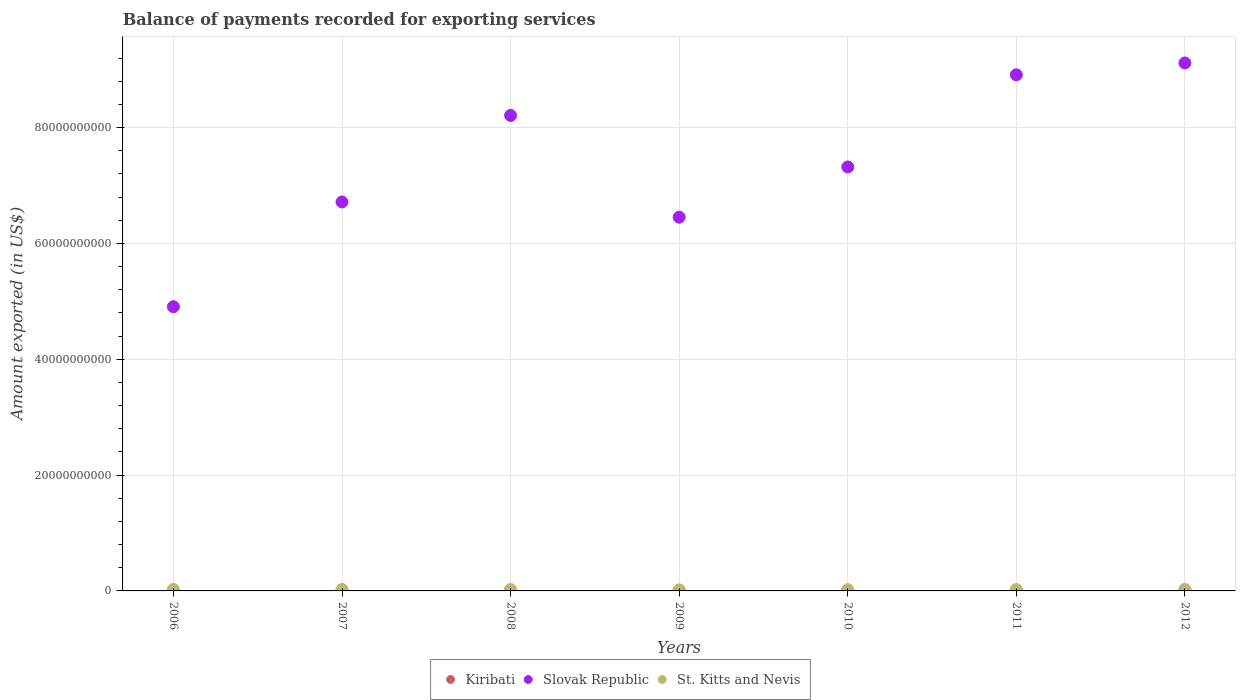What is the amount exported in St. Kitts and Nevis in 2008?
Offer a very short reply. 2.45e+08. Across all years, what is the maximum amount exported in St. Kitts and Nevis?
Ensure brevity in your answer.  2.63e+08. Across all years, what is the minimum amount exported in Slovak Republic?
Offer a terse response. 4.91e+1. In which year was the amount exported in Slovak Republic minimum?
Your answer should be very brief. 2006. What is the total amount exported in St. Kitts and Nevis in the graph?
Offer a terse response. 1.65e+09. What is the difference between the amount exported in Slovak Republic in 2009 and that in 2010?
Your response must be concise. -8.68e+09. What is the difference between the amount exported in St. Kitts and Nevis in 2011 and the amount exported in Kiribati in 2007?
Provide a succinct answer. 1.66e+08. What is the average amount exported in St. Kitts and Nevis per year?
Ensure brevity in your answer.  2.36e+08. In the year 2012, what is the difference between the amount exported in Slovak Republic and amount exported in St. Kitts and Nevis?
Offer a very short reply. 9.09e+1. What is the ratio of the amount exported in St. Kitts and Nevis in 2006 to that in 2012?
Provide a short and direct response. 0.95. Is the difference between the amount exported in Slovak Republic in 2008 and 2012 greater than the difference between the amount exported in St. Kitts and Nevis in 2008 and 2012?
Provide a succinct answer. No. What is the difference between the highest and the second highest amount exported in Kiribati?
Keep it short and to the point. 2.69e+07. What is the difference between the highest and the lowest amount exported in Kiribati?
Offer a terse response. 6.40e+07. In how many years, is the amount exported in St. Kitts and Nevis greater than the average amount exported in St. Kitts and Nevis taken over all years?
Give a very brief answer. 5. Is it the case that in every year, the sum of the amount exported in St. Kitts and Nevis and amount exported in Slovak Republic  is greater than the amount exported in Kiribati?
Make the answer very short. Yes. Does the amount exported in St. Kitts and Nevis monotonically increase over the years?
Keep it short and to the point. No. Is the amount exported in Kiribati strictly greater than the amount exported in St. Kitts and Nevis over the years?
Your answer should be very brief. No. How many dotlines are there?
Your answer should be very brief. 3. Are the values on the major ticks of Y-axis written in scientific E-notation?
Your answer should be very brief. No. Does the graph contain any zero values?
Your answer should be very brief. No. Does the graph contain grids?
Provide a short and direct response. Yes. Where does the legend appear in the graph?
Keep it short and to the point. Bottom center. What is the title of the graph?
Ensure brevity in your answer.  Balance of payments recorded for exporting services. What is the label or title of the Y-axis?
Your answer should be very brief. Amount exported (in US$). What is the Amount exported (in US$) in Kiribati in 2006?
Keep it short and to the point. 6.04e+07. What is the Amount exported (in US$) in Slovak Republic in 2006?
Ensure brevity in your answer.  4.91e+1. What is the Amount exported (in US$) of St. Kitts and Nevis in 2006?
Offer a terse response. 2.49e+08. What is the Amount exported (in US$) in Kiribati in 2007?
Your answer should be very brief. 8.29e+07. What is the Amount exported (in US$) of Slovak Republic in 2007?
Provide a short and direct response. 6.72e+1. What is the Amount exported (in US$) in St. Kitts and Nevis in 2007?
Keep it short and to the point. 2.48e+08. What is the Amount exported (in US$) in Kiribati in 2008?
Your answer should be very brief. 9.38e+07. What is the Amount exported (in US$) of Slovak Republic in 2008?
Offer a very short reply. 8.21e+1. What is the Amount exported (in US$) of St. Kitts and Nevis in 2008?
Offer a terse response. 2.45e+08. What is the Amount exported (in US$) of Kiribati in 2009?
Offer a terse response. 7.75e+07. What is the Amount exported (in US$) of Slovak Republic in 2009?
Your answer should be compact. 6.45e+1. What is the Amount exported (in US$) of St. Kitts and Nevis in 2009?
Offer a terse response. 1.85e+08. What is the Amount exported (in US$) of Kiribati in 2010?
Provide a short and direct response. 9.54e+07. What is the Amount exported (in US$) of Slovak Republic in 2010?
Keep it short and to the point. 7.32e+1. What is the Amount exported (in US$) in St. Kitts and Nevis in 2010?
Offer a terse response. 2.16e+08. What is the Amount exported (in US$) of Kiribati in 2011?
Keep it short and to the point. 9.75e+07. What is the Amount exported (in US$) of Slovak Republic in 2011?
Provide a short and direct response. 8.91e+1. What is the Amount exported (in US$) in St. Kitts and Nevis in 2011?
Your answer should be compact. 2.49e+08. What is the Amount exported (in US$) in Kiribati in 2012?
Provide a succinct answer. 1.24e+08. What is the Amount exported (in US$) in Slovak Republic in 2012?
Offer a terse response. 9.12e+1. What is the Amount exported (in US$) in St. Kitts and Nevis in 2012?
Your response must be concise. 2.63e+08. Across all years, what is the maximum Amount exported (in US$) in Kiribati?
Provide a succinct answer. 1.24e+08. Across all years, what is the maximum Amount exported (in US$) of Slovak Republic?
Ensure brevity in your answer.  9.12e+1. Across all years, what is the maximum Amount exported (in US$) in St. Kitts and Nevis?
Offer a very short reply. 2.63e+08. Across all years, what is the minimum Amount exported (in US$) of Kiribati?
Provide a succinct answer. 6.04e+07. Across all years, what is the minimum Amount exported (in US$) in Slovak Republic?
Make the answer very short. 4.91e+1. Across all years, what is the minimum Amount exported (in US$) of St. Kitts and Nevis?
Make the answer very short. 1.85e+08. What is the total Amount exported (in US$) of Kiribati in the graph?
Make the answer very short. 6.32e+08. What is the total Amount exported (in US$) of Slovak Republic in the graph?
Ensure brevity in your answer.  5.16e+11. What is the total Amount exported (in US$) of St. Kitts and Nevis in the graph?
Ensure brevity in your answer.  1.65e+09. What is the difference between the Amount exported (in US$) of Kiribati in 2006 and that in 2007?
Give a very brief answer. -2.25e+07. What is the difference between the Amount exported (in US$) in Slovak Republic in 2006 and that in 2007?
Make the answer very short. -1.81e+1. What is the difference between the Amount exported (in US$) of St. Kitts and Nevis in 2006 and that in 2007?
Your response must be concise. 1.23e+06. What is the difference between the Amount exported (in US$) of Kiribati in 2006 and that in 2008?
Keep it short and to the point. -3.34e+07. What is the difference between the Amount exported (in US$) in Slovak Republic in 2006 and that in 2008?
Provide a succinct answer. -3.30e+1. What is the difference between the Amount exported (in US$) of St. Kitts and Nevis in 2006 and that in 2008?
Your answer should be very brief. 4.29e+06. What is the difference between the Amount exported (in US$) of Kiribati in 2006 and that in 2009?
Make the answer very short. -1.72e+07. What is the difference between the Amount exported (in US$) of Slovak Republic in 2006 and that in 2009?
Offer a very short reply. -1.55e+1. What is the difference between the Amount exported (in US$) in St. Kitts and Nevis in 2006 and that in 2009?
Your response must be concise. 6.37e+07. What is the difference between the Amount exported (in US$) of Kiribati in 2006 and that in 2010?
Your answer should be compact. -3.50e+07. What is the difference between the Amount exported (in US$) in Slovak Republic in 2006 and that in 2010?
Your answer should be compact. -2.41e+1. What is the difference between the Amount exported (in US$) of St. Kitts and Nevis in 2006 and that in 2010?
Ensure brevity in your answer.  3.32e+07. What is the difference between the Amount exported (in US$) of Kiribati in 2006 and that in 2011?
Your answer should be compact. -3.71e+07. What is the difference between the Amount exported (in US$) of Slovak Republic in 2006 and that in 2011?
Your response must be concise. -4.01e+1. What is the difference between the Amount exported (in US$) of St. Kitts and Nevis in 2006 and that in 2011?
Make the answer very short. 5.48e+04. What is the difference between the Amount exported (in US$) of Kiribati in 2006 and that in 2012?
Give a very brief answer. -6.40e+07. What is the difference between the Amount exported (in US$) of Slovak Republic in 2006 and that in 2012?
Your response must be concise. -4.21e+1. What is the difference between the Amount exported (in US$) of St. Kitts and Nevis in 2006 and that in 2012?
Provide a short and direct response. -1.36e+07. What is the difference between the Amount exported (in US$) of Kiribati in 2007 and that in 2008?
Ensure brevity in your answer.  -1.09e+07. What is the difference between the Amount exported (in US$) of Slovak Republic in 2007 and that in 2008?
Offer a very short reply. -1.49e+1. What is the difference between the Amount exported (in US$) of St. Kitts and Nevis in 2007 and that in 2008?
Provide a succinct answer. 3.05e+06. What is the difference between the Amount exported (in US$) in Kiribati in 2007 and that in 2009?
Offer a terse response. 5.38e+06. What is the difference between the Amount exported (in US$) in Slovak Republic in 2007 and that in 2009?
Keep it short and to the point. 2.63e+09. What is the difference between the Amount exported (in US$) of St. Kitts and Nevis in 2007 and that in 2009?
Keep it short and to the point. 6.25e+07. What is the difference between the Amount exported (in US$) of Kiribati in 2007 and that in 2010?
Provide a succinct answer. -1.25e+07. What is the difference between the Amount exported (in US$) in Slovak Republic in 2007 and that in 2010?
Your answer should be compact. -6.05e+09. What is the difference between the Amount exported (in US$) of St. Kitts and Nevis in 2007 and that in 2010?
Make the answer very short. 3.19e+07. What is the difference between the Amount exported (in US$) in Kiribati in 2007 and that in 2011?
Keep it short and to the point. -1.46e+07. What is the difference between the Amount exported (in US$) of Slovak Republic in 2007 and that in 2011?
Your answer should be very brief. -2.20e+1. What is the difference between the Amount exported (in US$) of St. Kitts and Nevis in 2007 and that in 2011?
Offer a very short reply. -1.18e+06. What is the difference between the Amount exported (in US$) of Kiribati in 2007 and that in 2012?
Your answer should be compact. -4.15e+07. What is the difference between the Amount exported (in US$) of Slovak Republic in 2007 and that in 2012?
Offer a terse response. -2.40e+1. What is the difference between the Amount exported (in US$) of St. Kitts and Nevis in 2007 and that in 2012?
Make the answer very short. -1.48e+07. What is the difference between the Amount exported (in US$) in Kiribati in 2008 and that in 2009?
Offer a terse response. 1.63e+07. What is the difference between the Amount exported (in US$) of Slovak Republic in 2008 and that in 2009?
Make the answer very short. 1.76e+1. What is the difference between the Amount exported (in US$) of St. Kitts and Nevis in 2008 and that in 2009?
Ensure brevity in your answer.  5.94e+07. What is the difference between the Amount exported (in US$) in Kiribati in 2008 and that in 2010?
Your response must be concise. -1.56e+06. What is the difference between the Amount exported (in US$) of Slovak Republic in 2008 and that in 2010?
Offer a terse response. 8.89e+09. What is the difference between the Amount exported (in US$) in St. Kitts and Nevis in 2008 and that in 2010?
Offer a terse response. 2.89e+07. What is the difference between the Amount exported (in US$) of Kiribati in 2008 and that in 2011?
Your answer should be very brief. -3.68e+06. What is the difference between the Amount exported (in US$) in Slovak Republic in 2008 and that in 2011?
Make the answer very short. -7.02e+09. What is the difference between the Amount exported (in US$) in St. Kitts and Nevis in 2008 and that in 2011?
Offer a terse response. -4.23e+06. What is the difference between the Amount exported (in US$) in Kiribati in 2008 and that in 2012?
Your answer should be compact. -3.05e+07. What is the difference between the Amount exported (in US$) in Slovak Republic in 2008 and that in 2012?
Give a very brief answer. -9.07e+09. What is the difference between the Amount exported (in US$) in St. Kitts and Nevis in 2008 and that in 2012?
Offer a terse response. -1.79e+07. What is the difference between the Amount exported (in US$) in Kiribati in 2009 and that in 2010?
Offer a very short reply. -1.79e+07. What is the difference between the Amount exported (in US$) of Slovak Republic in 2009 and that in 2010?
Your response must be concise. -8.68e+09. What is the difference between the Amount exported (in US$) of St. Kitts and Nevis in 2009 and that in 2010?
Keep it short and to the point. -3.06e+07. What is the difference between the Amount exported (in US$) of Kiribati in 2009 and that in 2011?
Provide a short and direct response. -2.00e+07. What is the difference between the Amount exported (in US$) of Slovak Republic in 2009 and that in 2011?
Ensure brevity in your answer.  -2.46e+1. What is the difference between the Amount exported (in US$) of St. Kitts and Nevis in 2009 and that in 2011?
Your response must be concise. -6.37e+07. What is the difference between the Amount exported (in US$) in Kiribati in 2009 and that in 2012?
Keep it short and to the point. -4.68e+07. What is the difference between the Amount exported (in US$) in Slovak Republic in 2009 and that in 2012?
Provide a short and direct response. -2.66e+1. What is the difference between the Amount exported (in US$) in St. Kitts and Nevis in 2009 and that in 2012?
Provide a short and direct response. -7.73e+07. What is the difference between the Amount exported (in US$) of Kiribati in 2010 and that in 2011?
Your answer should be very brief. -2.12e+06. What is the difference between the Amount exported (in US$) in Slovak Republic in 2010 and that in 2011?
Your answer should be very brief. -1.59e+1. What is the difference between the Amount exported (in US$) of St. Kitts and Nevis in 2010 and that in 2011?
Provide a short and direct response. -3.31e+07. What is the difference between the Amount exported (in US$) in Kiribati in 2010 and that in 2012?
Ensure brevity in your answer.  -2.90e+07. What is the difference between the Amount exported (in US$) in Slovak Republic in 2010 and that in 2012?
Offer a very short reply. -1.80e+1. What is the difference between the Amount exported (in US$) of St. Kitts and Nevis in 2010 and that in 2012?
Provide a short and direct response. -4.67e+07. What is the difference between the Amount exported (in US$) of Kiribati in 2011 and that in 2012?
Provide a succinct answer. -2.69e+07. What is the difference between the Amount exported (in US$) in Slovak Republic in 2011 and that in 2012?
Ensure brevity in your answer.  -2.05e+09. What is the difference between the Amount exported (in US$) in St. Kitts and Nevis in 2011 and that in 2012?
Ensure brevity in your answer.  -1.36e+07. What is the difference between the Amount exported (in US$) of Kiribati in 2006 and the Amount exported (in US$) of Slovak Republic in 2007?
Give a very brief answer. -6.71e+1. What is the difference between the Amount exported (in US$) in Kiribati in 2006 and the Amount exported (in US$) in St. Kitts and Nevis in 2007?
Your response must be concise. -1.87e+08. What is the difference between the Amount exported (in US$) of Slovak Republic in 2006 and the Amount exported (in US$) of St. Kitts and Nevis in 2007?
Your answer should be compact. 4.88e+1. What is the difference between the Amount exported (in US$) of Kiribati in 2006 and the Amount exported (in US$) of Slovak Republic in 2008?
Ensure brevity in your answer.  -8.20e+1. What is the difference between the Amount exported (in US$) in Kiribati in 2006 and the Amount exported (in US$) in St. Kitts and Nevis in 2008?
Give a very brief answer. -1.84e+08. What is the difference between the Amount exported (in US$) in Slovak Republic in 2006 and the Amount exported (in US$) in St. Kitts and Nevis in 2008?
Provide a short and direct response. 4.88e+1. What is the difference between the Amount exported (in US$) in Kiribati in 2006 and the Amount exported (in US$) in Slovak Republic in 2009?
Provide a short and direct response. -6.45e+1. What is the difference between the Amount exported (in US$) in Kiribati in 2006 and the Amount exported (in US$) in St. Kitts and Nevis in 2009?
Ensure brevity in your answer.  -1.25e+08. What is the difference between the Amount exported (in US$) of Slovak Republic in 2006 and the Amount exported (in US$) of St. Kitts and Nevis in 2009?
Offer a very short reply. 4.89e+1. What is the difference between the Amount exported (in US$) in Kiribati in 2006 and the Amount exported (in US$) in Slovak Republic in 2010?
Offer a terse response. -7.32e+1. What is the difference between the Amount exported (in US$) of Kiribati in 2006 and the Amount exported (in US$) of St. Kitts and Nevis in 2010?
Your answer should be compact. -1.55e+08. What is the difference between the Amount exported (in US$) in Slovak Republic in 2006 and the Amount exported (in US$) in St. Kitts and Nevis in 2010?
Give a very brief answer. 4.89e+1. What is the difference between the Amount exported (in US$) in Kiribati in 2006 and the Amount exported (in US$) in Slovak Republic in 2011?
Keep it short and to the point. -8.91e+1. What is the difference between the Amount exported (in US$) of Kiribati in 2006 and the Amount exported (in US$) of St. Kitts and Nevis in 2011?
Offer a very short reply. -1.89e+08. What is the difference between the Amount exported (in US$) of Slovak Republic in 2006 and the Amount exported (in US$) of St. Kitts and Nevis in 2011?
Offer a terse response. 4.88e+1. What is the difference between the Amount exported (in US$) in Kiribati in 2006 and the Amount exported (in US$) in Slovak Republic in 2012?
Your answer should be compact. -9.11e+1. What is the difference between the Amount exported (in US$) in Kiribati in 2006 and the Amount exported (in US$) in St. Kitts and Nevis in 2012?
Your answer should be very brief. -2.02e+08. What is the difference between the Amount exported (in US$) in Slovak Republic in 2006 and the Amount exported (in US$) in St. Kitts and Nevis in 2012?
Provide a succinct answer. 4.88e+1. What is the difference between the Amount exported (in US$) of Kiribati in 2007 and the Amount exported (in US$) of Slovak Republic in 2008?
Give a very brief answer. -8.20e+1. What is the difference between the Amount exported (in US$) in Kiribati in 2007 and the Amount exported (in US$) in St. Kitts and Nevis in 2008?
Your answer should be compact. -1.62e+08. What is the difference between the Amount exported (in US$) of Slovak Republic in 2007 and the Amount exported (in US$) of St. Kitts and Nevis in 2008?
Provide a short and direct response. 6.69e+1. What is the difference between the Amount exported (in US$) of Kiribati in 2007 and the Amount exported (in US$) of Slovak Republic in 2009?
Make the answer very short. -6.45e+1. What is the difference between the Amount exported (in US$) in Kiribati in 2007 and the Amount exported (in US$) in St. Kitts and Nevis in 2009?
Your answer should be compact. -1.02e+08. What is the difference between the Amount exported (in US$) in Slovak Republic in 2007 and the Amount exported (in US$) in St. Kitts and Nevis in 2009?
Your response must be concise. 6.70e+1. What is the difference between the Amount exported (in US$) in Kiribati in 2007 and the Amount exported (in US$) in Slovak Republic in 2010?
Keep it short and to the point. -7.31e+1. What is the difference between the Amount exported (in US$) of Kiribati in 2007 and the Amount exported (in US$) of St. Kitts and Nevis in 2010?
Offer a terse response. -1.33e+08. What is the difference between the Amount exported (in US$) of Slovak Republic in 2007 and the Amount exported (in US$) of St. Kitts and Nevis in 2010?
Ensure brevity in your answer.  6.70e+1. What is the difference between the Amount exported (in US$) in Kiribati in 2007 and the Amount exported (in US$) in Slovak Republic in 2011?
Make the answer very short. -8.90e+1. What is the difference between the Amount exported (in US$) in Kiribati in 2007 and the Amount exported (in US$) in St. Kitts and Nevis in 2011?
Provide a succinct answer. -1.66e+08. What is the difference between the Amount exported (in US$) of Slovak Republic in 2007 and the Amount exported (in US$) of St. Kitts and Nevis in 2011?
Provide a short and direct response. 6.69e+1. What is the difference between the Amount exported (in US$) of Kiribati in 2007 and the Amount exported (in US$) of Slovak Republic in 2012?
Offer a very short reply. -9.11e+1. What is the difference between the Amount exported (in US$) in Kiribati in 2007 and the Amount exported (in US$) in St. Kitts and Nevis in 2012?
Offer a very short reply. -1.80e+08. What is the difference between the Amount exported (in US$) in Slovak Republic in 2007 and the Amount exported (in US$) in St. Kitts and Nevis in 2012?
Provide a short and direct response. 6.69e+1. What is the difference between the Amount exported (in US$) of Kiribati in 2008 and the Amount exported (in US$) of Slovak Republic in 2009?
Your answer should be compact. -6.44e+1. What is the difference between the Amount exported (in US$) in Kiribati in 2008 and the Amount exported (in US$) in St. Kitts and Nevis in 2009?
Provide a short and direct response. -9.14e+07. What is the difference between the Amount exported (in US$) in Slovak Republic in 2008 and the Amount exported (in US$) in St. Kitts and Nevis in 2009?
Your answer should be compact. 8.19e+1. What is the difference between the Amount exported (in US$) in Kiribati in 2008 and the Amount exported (in US$) in Slovak Republic in 2010?
Offer a terse response. -7.31e+1. What is the difference between the Amount exported (in US$) of Kiribati in 2008 and the Amount exported (in US$) of St. Kitts and Nevis in 2010?
Keep it short and to the point. -1.22e+08. What is the difference between the Amount exported (in US$) in Slovak Republic in 2008 and the Amount exported (in US$) in St. Kitts and Nevis in 2010?
Your answer should be very brief. 8.19e+1. What is the difference between the Amount exported (in US$) in Kiribati in 2008 and the Amount exported (in US$) in Slovak Republic in 2011?
Offer a very short reply. -8.90e+1. What is the difference between the Amount exported (in US$) of Kiribati in 2008 and the Amount exported (in US$) of St. Kitts and Nevis in 2011?
Keep it short and to the point. -1.55e+08. What is the difference between the Amount exported (in US$) of Slovak Republic in 2008 and the Amount exported (in US$) of St. Kitts and Nevis in 2011?
Offer a terse response. 8.19e+1. What is the difference between the Amount exported (in US$) in Kiribati in 2008 and the Amount exported (in US$) in Slovak Republic in 2012?
Make the answer very short. -9.11e+1. What is the difference between the Amount exported (in US$) of Kiribati in 2008 and the Amount exported (in US$) of St. Kitts and Nevis in 2012?
Provide a succinct answer. -1.69e+08. What is the difference between the Amount exported (in US$) in Slovak Republic in 2008 and the Amount exported (in US$) in St. Kitts and Nevis in 2012?
Your answer should be compact. 8.18e+1. What is the difference between the Amount exported (in US$) in Kiribati in 2009 and the Amount exported (in US$) in Slovak Republic in 2010?
Make the answer very short. -7.31e+1. What is the difference between the Amount exported (in US$) of Kiribati in 2009 and the Amount exported (in US$) of St. Kitts and Nevis in 2010?
Your answer should be very brief. -1.38e+08. What is the difference between the Amount exported (in US$) of Slovak Republic in 2009 and the Amount exported (in US$) of St. Kitts and Nevis in 2010?
Your answer should be very brief. 6.43e+1. What is the difference between the Amount exported (in US$) in Kiribati in 2009 and the Amount exported (in US$) in Slovak Republic in 2011?
Give a very brief answer. -8.90e+1. What is the difference between the Amount exported (in US$) in Kiribati in 2009 and the Amount exported (in US$) in St. Kitts and Nevis in 2011?
Your answer should be compact. -1.71e+08. What is the difference between the Amount exported (in US$) in Slovak Republic in 2009 and the Amount exported (in US$) in St. Kitts and Nevis in 2011?
Offer a very short reply. 6.43e+1. What is the difference between the Amount exported (in US$) of Kiribati in 2009 and the Amount exported (in US$) of Slovak Republic in 2012?
Your answer should be very brief. -9.11e+1. What is the difference between the Amount exported (in US$) of Kiribati in 2009 and the Amount exported (in US$) of St. Kitts and Nevis in 2012?
Keep it short and to the point. -1.85e+08. What is the difference between the Amount exported (in US$) in Slovak Republic in 2009 and the Amount exported (in US$) in St. Kitts and Nevis in 2012?
Your response must be concise. 6.43e+1. What is the difference between the Amount exported (in US$) in Kiribati in 2010 and the Amount exported (in US$) in Slovak Republic in 2011?
Offer a terse response. -8.90e+1. What is the difference between the Amount exported (in US$) of Kiribati in 2010 and the Amount exported (in US$) of St. Kitts and Nevis in 2011?
Provide a short and direct response. -1.54e+08. What is the difference between the Amount exported (in US$) of Slovak Republic in 2010 and the Amount exported (in US$) of St. Kitts and Nevis in 2011?
Offer a terse response. 7.30e+1. What is the difference between the Amount exported (in US$) of Kiribati in 2010 and the Amount exported (in US$) of Slovak Republic in 2012?
Your answer should be compact. -9.11e+1. What is the difference between the Amount exported (in US$) in Kiribati in 2010 and the Amount exported (in US$) in St. Kitts and Nevis in 2012?
Make the answer very short. -1.67e+08. What is the difference between the Amount exported (in US$) of Slovak Republic in 2010 and the Amount exported (in US$) of St. Kitts and Nevis in 2012?
Provide a succinct answer. 7.30e+1. What is the difference between the Amount exported (in US$) of Kiribati in 2011 and the Amount exported (in US$) of Slovak Republic in 2012?
Give a very brief answer. -9.11e+1. What is the difference between the Amount exported (in US$) of Kiribati in 2011 and the Amount exported (in US$) of St. Kitts and Nevis in 2012?
Your answer should be compact. -1.65e+08. What is the difference between the Amount exported (in US$) of Slovak Republic in 2011 and the Amount exported (in US$) of St. Kitts and Nevis in 2012?
Keep it short and to the point. 8.89e+1. What is the average Amount exported (in US$) of Kiribati per year?
Provide a short and direct response. 9.03e+07. What is the average Amount exported (in US$) of Slovak Republic per year?
Provide a short and direct response. 7.38e+1. What is the average Amount exported (in US$) of St. Kitts and Nevis per year?
Provide a succinct answer. 2.36e+08. In the year 2006, what is the difference between the Amount exported (in US$) of Kiribati and Amount exported (in US$) of Slovak Republic?
Ensure brevity in your answer.  -4.90e+1. In the year 2006, what is the difference between the Amount exported (in US$) in Kiribati and Amount exported (in US$) in St. Kitts and Nevis?
Offer a terse response. -1.89e+08. In the year 2006, what is the difference between the Amount exported (in US$) in Slovak Republic and Amount exported (in US$) in St. Kitts and Nevis?
Ensure brevity in your answer.  4.88e+1. In the year 2007, what is the difference between the Amount exported (in US$) of Kiribati and Amount exported (in US$) of Slovak Republic?
Offer a terse response. -6.71e+1. In the year 2007, what is the difference between the Amount exported (in US$) of Kiribati and Amount exported (in US$) of St. Kitts and Nevis?
Give a very brief answer. -1.65e+08. In the year 2007, what is the difference between the Amount exported (in US$) in Slovak Republic and Amount exported (in US$) in St. Kitts and Nevis?
Offer a terse response. 6.69e+1. In the year 2008, what is the difference between the Amount exported (in US$) of Kiribati and Amount exported (in US$) of Slovak Republic?
Provide a short and direct response. -8.20e+1. In the year 2008, what is the difference between the Amount exported (in US$) of Kiribati and Amount exported (in US$) of St. Kitts and Nevis?
Offer a very short reply. -1.51e+08. In the year 2008, what is the difference between the Amount exported (in US$) in Slovak Republic and Amount exported (in US$) in St. Kitts and Nevis?
Offer a very short reply. 8.19e+1. In the year 2009, what is the difference between the Amount exported (in US$) in Kiribati and Amount exported (in US$) in Slovak Republic?
Keep it short and to the point. -6.45e+1. In the year 2009, what is the difference between the Amount exported (in US$) of Kiribati and Amount exported (in US$) of St. Kitts and Nevis?
Offer a very short reply. -1.08e+08. In the year 2009, what is the difference between the Amount exported (in US$) in Slovak Republic and Amount exported (in US$) in St. Kitts and Nevis?
Provide a short and direct response. 6.44e+1. In the year 2010, what is the difference between the Amount exported (in US$) of Kiribati and Amount exported (in US$) of Slovak Republic?
Provide a succinct answer. -7.31e+1. In the year 2010, what is the difference between the Amount exported (in US$) in Kiribati and Amount exported (in US$) in St. Kitts and Nevis?
Give a very brief answer. -1.20e+08. In the year 2010, what is the difference between the Amount exported (in US$) of Slovak Republic and Amount exported (in US$) of St. Kitts and Nevis?
Your answer should be very brief. 7.30e+1. In the year 2011, what is the difference between the Amount exported (in US$) in Kiribati and Amount exported (in US$) in Slovak Republic?
Ensure brevity in your answer.  -8.90e+1. In the year 2011, what is the difference between the Amount exported (in US$) of Kiribati and Amount exported (in US$) of St. Kitts and Nevis?
Offer a terse response. -1.51e+08. In the year 2011, what is the difference between the Amount exported (in US$) of Slovak Republic and Amount exported (in US$) of St. Kitts and Nevis?
Ensure brevity in your answer.  8.89e+1. In the year 2012, what is the difference between the Amount exported (in US$) in Kiribati and Amount exported (in US$) in Slovak Republic?
Offer a terse response. -9.10e+1. In the year 2012, what is the difference between the Amount exported (in US$) in Kiribati and Amount exported (in US$) in St. Kitts and Nevis?
Your answer should be very brief. -1.38e+08. In the year 2012, what is the difference between the Amount exported (in US$) of Slovak Republic and Amount exported (in US$) of St. Kitts and Nevis?
Give a very brief answer. 9.09e+1. What is the ratio of the Amount exported (in US$) in Kiribati in 2006 to that in 2007?
Your response must be concise. 0.73. What is the ratio of the Amount exported (in US$) of Slovak Republic in 2006 to that in 2007?
Offer a very short reply. 0.73. What is the ratio of the Amount exported (in US$) in St. Kitts and Nevis in 2006 to that in 2007?
Your response must be concise. 1. What is the ratio of the Amount exported (in US$) of Kiribati in 2006 to that in 2008?
Offer a very short reply. 0.64. What is the ratio of the Amount exported (in US$) in Slovak Republic in 2006 to that in 2008?
Ensure brevity in your answer.  0.6. What is the ratio of the Amount exported (in US$) in St. Kitts and Nevis in 2006 to that in 2008?
Your answer should be very brief. 1.02. What is the ratio of the Amount exported (in US$) of Kiribati in 2006 to that in 2009?
Your answer should be very brief. 0.78. What is the ratio of the Amount exported (in US$) of Slovak Republic in 2006 to that in 2009?
Offer a very short reply. 0.76. What is the ratio of the Amount exported (in US$) of St. Kitts and Nevis in 2006 to that in 2009?
Keep it short and to the point. 1.34. What is the ratio of the Amount exported (in US$) in Kiribati in 2006 to that in 2010?
Keep it short and to the point. 0.63. What is the ratio of the Amount exported (in US$) in Slovak Republic in 2006 to that in 2010?
Make the answer very short. 0.67. What is the ratio of the Amount exported (in US$) in St. Kitts and Nevis in 2006 to that in 2010?
Keep it short and to the point. 1.15. What is the ratio of the Amount exported (in US$) of Kiribati in 2006 to that in 2011?
Your answer should be compact. 0.62. What is the ratio of the Amount exported (in US$) of Slovak Republic in 2006 to that in 2011?
Keep it short and to the point. 0.55. What is the ratio of the Amount exported (in US$) of St. Kitts and Nevis in 2006 to that in 2011?
Ensure brevity in your answer.  1. What is the ratio of the Amount exported (in US$) in Kiribati in 2006 to that in 2012?
Your answer should be compact. 0.49. What is the ratio of the Amount exported (in US$) in Slovak Republic in 2006 to that in 2012?
Offer a terse response. 0.54. What is the ratio of the Amount exported (in US$) in St. Kitts and Nevis in 2006 to that in 2012?
Offer a very short reply. 0.95. What is the ratio of the Amount exported (in US$) in Kiribati in 2007 to that in 2008?
Your answer should be compact. 0.88. What is the ratio of the Amount exported (in US$) in Slovak Republic in 2007 to that in 2008?
Your response must be concise. 0.82. What is the ratio of the Amount exported (in US$) in St. Kitts and Nevis in 2007 to that in 2008?
Ensure brevity in your answer.  1.01. What is the ratio of the Amount exported (in US$) in Kiribati in 2007 to that in 2009?
Your answer should be very brief. 1.07. What is the ratio of the Amount exported (in US$) in Slovak Republic in 2007 to that in 2009?
Make the answer very short. 1.04. What is the ratio of the Amount exported (in US$) of St. Kitts and Nevis in 2007 to that in 2009?
Ensure brevity in your answer.  1.34. What is the ratio of the Amount exported (in US$) in Kiribati in 2007 to that in 2010?
Make the answer very short. 0.87. What is the ratio of the Amount exported (in US$) of Slovak Republic in 2007 to that in 2010?
Keep it short and to the point. 0.92. What is the ratio of the Amount exported (in US$) of St. Kitts and Nevis in 2007 to that in 2010?
Make the answer very short. 1.15. What is the ratio of the Amount exported (in US$) in Kiribati in 2007 to that in 2011?
Make the answer very short. 0.85. What is the ratio of the Amount exported (in US$) of Slovak Republic in 2007 to that in 2011?
Offer a terse response. 0.75. What is the ratio of the Amount exported (in US$) in St. Kitts and Nevis in 2007 to that in 2011?
Your answer should be very brief. 1. What is the ratio of the Amount exported (in US$) in Slovak Republic in 2007 to that in 2012?
Ensure brevity in your answer.  0.74. What is the ratio of the Amount exported (in US$) of St. Kitts and Nevis in 2007 to that in 2012?
Provide a succinct answer. 0.94. What is the ratio of the Amount exported (in US$) of Kiribati in 2008 to that in 2009?
Your response must be concise. 1.21. What is the ratio of the Amount exported (in US$) of Slovak Republic in 2008 to that in 2009?
Ensure brevity in your answer.  1.27. What is the ratio of the Amount exported (in US$) of St. Kitts and Nevis in 2008 to that in 2009?
Offer a terse response. 1.32. What is the ratio of the Amount exported (in US$) in Kiribati in 2008 to that in 2010?
Offer a very short reply. 0.98. What is the ratio of the Amount exported (in US$) in Slovak Republic in 2008 to that in 2010?
Your answer should be very brief. 1.12. What is the ratio of the Amount exported (in US$) in St. Kitts and Nevis in 2008 to that in 2010?
Offer a very short reply. 1.13. What is the ratio of the Amount exported (in US$) in Kiribati in 2008 to that in 2011?
Your response must be concise. 0.96. What is the ratio of the Amount exported (in US$) in Slovak Republic in 2008 to that in 2011?
Offer a very short reply. 0.92. What is the ratio of the Amount exported (in US$) of Kiribati in 2008 to that in 2012?
Offer a terse response. 0.75. What is the ratio of the Amount exported (in US$) in Slovak Republic in 2008 to that in 2012?
Provide a short and direct response. 0.9. What is the ratio of the Amount exported (in US$) in St. Kitts and Nevis in 2008 to that in 2012?
Ensure brevity in your answer.  0.93. What is the ratio of the Amount exported (in US$) in Kiribati in 2009 to that in 2010?
Your answer should be very brief. 0.81. What is the ratio of the Amount exported (in US$) in Slovak Republic in 2009 to that in 2010?
Your answer should be compact. 0.88. What is the ratio of the Amount exported (in US$) in St. Kitts and Nevis in 2009 to that in 2010?
Provide a succinct answer. 0.86. What is the ratio of the Amount exported (in US$) in Kiribati in 2009 to that in 2011?
Ensure brevity in your answer.  0.8. What is the ratio of the Amount exported (in US$) in Slovak Republic in 2009 to that in 2011?
Offer a very short reply. 0.72. What is the ratio of the Amount exported (in US$) of St. Kitts and Nevis in 2009 to that in 2011?
Make the answer very short. 0.74. What is the ratio of the Amount exported (in US$) in Kiribati in 2009 to that in 2012?
Give a very brief answer. 0.62. What is the ratio of the Amount exported (in US$) of Slovak Republic in 2009 to that in 2012?
Provide a short and direct response. 0.71. What is the ratio of the Amount exported (in US$) of St. Kitts and Nevis in 2009 to that in 2012?
Offer a very short reply. 0.71. What is the ratio of the Amount exported (in US$) of Kiribati in 2010 to that in 2011?
Your answer should be very brief. 0.98. What is the ratio of the Amount exported (in US$) in Slovak Republic in 2010 to that in 2011?
Your answer should be compact. 0.82. What is the ratio of the Amount exported (in US$) of St. Kitts and Nevis in 2010 to that in 2011?
Ensure brevity in your answer.  0.87. What is the ratio of the Amount exported (in US$) in Kiribati in 2010 to that in 2012?
Provide a succinct answer. 0.77. What is the ratio of the Amount exported (in US$) of Slovak Republic in 2010 to that in 2012?
Keep it short and to the point. 0.8. What is the ratio of the Amount exported (in US$) in St. Kitts and Nevis in 2010 to that in 2012?
Your answer should be very brief. 0.82. What is the ratio of the Amount exported (in US$) in Kiribati in 2011 to that in 2012?
Your response must be concise. 0.78. What is the ratio of the Amount exported (in US$) of Slovak Republic in 2011 to that in 2012?
Your answer should be very brief. 0.98. What is the ratio of the Amount exported (in US$) of St. Kitts and Nevis in 2011 to that in 2012?
Your response must be concise. 0.95. What is the difference between the highest and the second highest Amount exported (in US$) of Kiribati?
Keep it short and to the point. 2.69e+07. What is the difference between the highest and the second highest Amount exported (in US$) of Slovak Republic?
Offer a very short reply. 2.05e+09. What is the difference between the highest and the second highest Amount exported (in US$) in St. Kitts and Nevis?
Offer a terse response. 1.36e+07. What is the difference between the highest and the lowest Amount exported (in US$) of Kiribati?
Your response must be concise. 6.40e+07. What is the difference between the highest and the lowest Amount exported (in US$) of Slovak Republic?
Your answer should be very brief. 4.21e+1. What is the difference between the highest and the lowest Amount exported (in US$) of St. Kitts and Nevis?
Ensure brevity in your answer.  7.73e+07. 